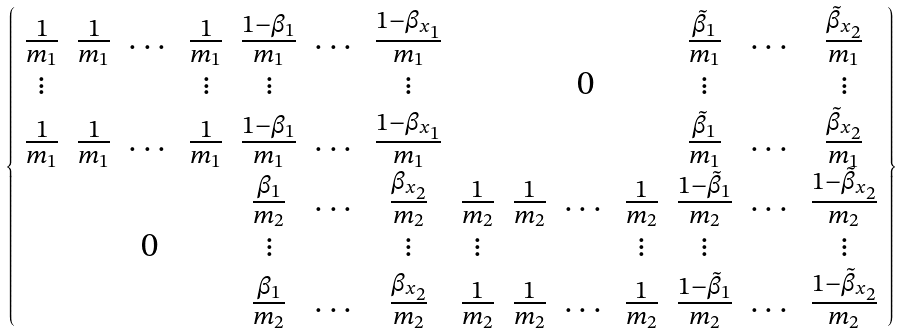<formula> <loc_0><loc_0><loc_500><loc_500>\left \{ \begin{array} { c c c c c c c c c c c c c c } \frac { 1 } { m _ { 1 } } & \frac { 1 } { m _ { 1 } } & \dots & \frac { 1 } { m _ { 1 } } & \frac { 1 - \beta _ { 1 } } { m _ { 1 } } & \dots & \frac { 1 - \beta _ { x _ { 1 } } } { m _ { 1 } } & & & & & \frac { \tilde { \beta } _ { 1 } } { m _ { 1 } } & \dots & \frac { \tilde { \beta } _ { x _ { 2 } } } { m _ { 1 } } \\ \vdots & & & \vdots & \vdots & & \vdots & & & 0 & & \vdots & & \vdots \\ \frac { 1 } { m _ { 1 } } & \frac { 1 } { m _ { 1 } } & \dots & \frac { 1 } { m _ { 1 } } & \frac { 1 - \beta _ { 1 } } { m _ { 1 } } & \dots & \frac { 1 - \beta _ { x _ { 1 } } } { m _ { 1 } } & & & & & \frac { \tilde { \beta } _ { 1 } } { m _ { 1 } } & \dots & \frac { \tilde { \beta } _ { x _ { 2 } } } { m _ { 1 } } \\ & & & & \frac { \beta _ { 1 } } { m _ { 2 } } & \dots & \frac { \beta _ { x _ { 2 } } } { m _ { 2 } } & \frac { 1 } { m _ { 2 } } & \frac { 1 } { m _ { 2 } } & \dots & \frac { 1 } { m _ { 2 } } & \frac { 1 - \tilde { \beta } _ { 1 } } { m _ { 2 } } & \dots & \frac { 1 - \tilde { \beta } _ { x _ { 2 } } } { m _ { 2 } } \\ & & 0 & & \vdots & & \vdots & \vdots & & & \vdots & \vdots & & \vdots \\ & & & & \frac { \beta _ { 1 } } { m _ { 2 } } & \dots & \frac { \beta _ { x _ { 2 } } } { m _ { 2 } } & \frac { 1 } { m _ { 2 } } & \frac { 1 } { m _ { 2 } } & \dots & \frac { 1 } { m _ { 2 } } & \frac { 1 - \tilde { \beta } _ { 1 } } { m _ { 2 } } & \dots & \frac { 1 - \tilde { \beta } _ { x _ { 2 } } } { m _ { 2 } } \\ \end{array} \right \}</formula> 